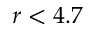<formula> <loc_0><loc_0><loc_500><loc_500>r < 4 . 7</formula> 